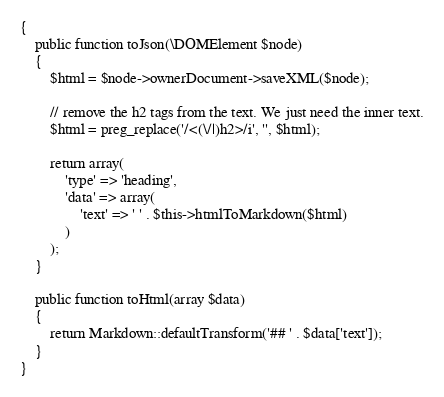Convert code to text. <code><loc_0><loc_0><loc_500><loc_500><_PHP_>{
    public function toJson(\DOMElement $node)
    {
        $html = $node->ownerDocument->saveXML($node);

        // remove the h2 tags from the text. We just need the inner text.
        $html = preg_replace('/<(\/|)h2>/i', '', $html);

        return array(
            'type' => 'heading',
            'data' => array(
                'text' => ' ' . $this->htmlToMarkdown($html)
            )
        );
    }

    public function toHtml(array $data)
    {
        return Markdown::defaultTransform('## ' . $data['text']);
    }
}
</code> 